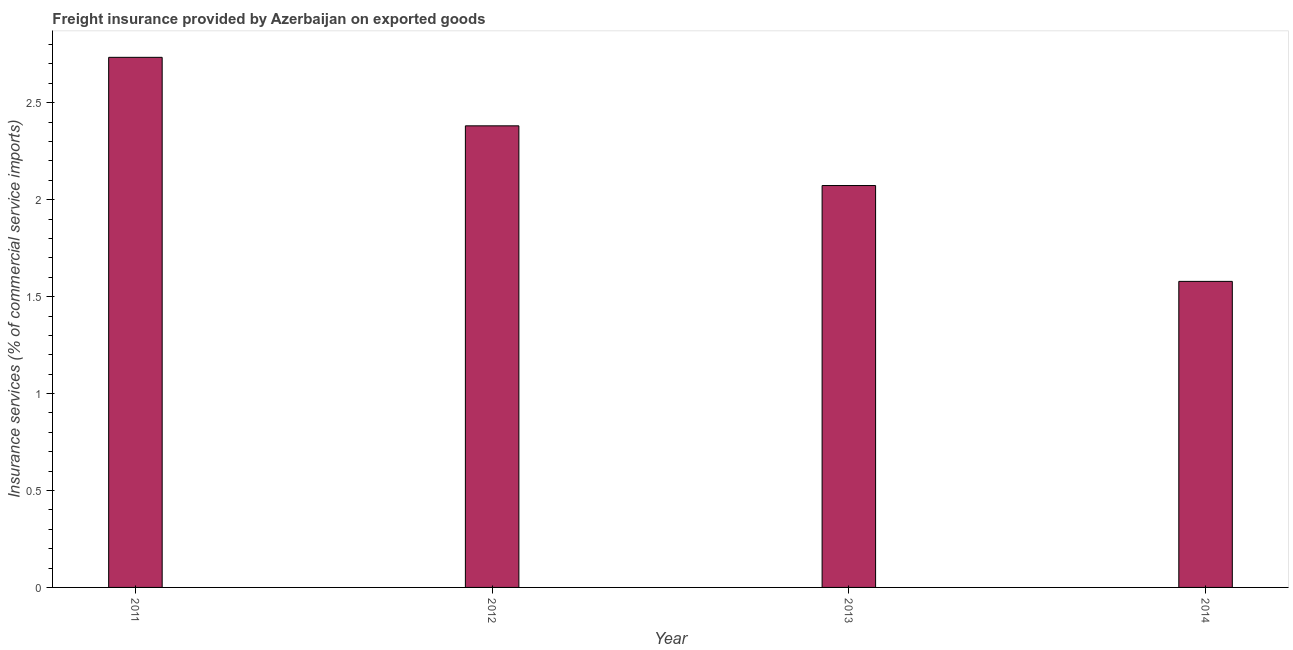What is the title of the graph?
Offer a terse response. Freight insurance provided by Azerbaijan on exported goods . What is the label or title of the Y-axis?
Provide a succinct answer. Insurance services (% of commercial service imports). What is the freight insurance in 2011?
Ensure brevity in your answer.  2.73. Across all years, what is the maximum freight insurance?
Your answer should be compact. 2.73. Across all years, what is the minimum freight insurance?
Your answer should be compact. 1.58. In which year was the freight insurance maximum?
Provide a succinct answer. 2011. In which year was the freight insurance minimum?
Offer a very short reply. 2014. What is the sum of the freight insurance?
Keep it short and to the point. 8.77. What is the difference between the freight insurance in 2012 and 2013?
Ensure brevity in your answer.  0.31. What is the average freight insurance per year?
Keep it short and to the point. 2.19. What is the median freight insurance?
Give a very brief answer. 2.23. In how many years, is the freight insurance greater than 2.7 %?
Make the answer very short. 1. What is the ratio of the freight insurance in 2011 to that in 2013?
Provide a short and direct response. 1.32. Is the freight insurance in 2011 less than that in 2014?
Your answer should be very brief. No. Is the difference between the freight insurance in 2011 and 2014 greater than the difference between any two years?
Offer a very short reply. Yes. What is the difference between the highest and the second highest freight insurance?
Make the answer very short. 0.35. Is the sum of the freight insurance in 2012 and 2013 greater than the maximum freight insurance across all years?
Give a very brief answer. Yes. What is the difference between the highest and the lowest freight insurance?
Offer a terse response. 1.16. In how many years, is the freight insurance greater than the average freight insurance taken over all years?
Make the answer very short. 2. Are all the bars in the graph horizontal?
Ensure brevity in your answer.  No. How many years are there in the graph?
Your answer should be compact. 4. What is the Insurance services (% of commercial service imports) of 2011?
Give a very brief answer. 2.73. What is the Insurance services (% of commercial service imports) of 2012?
Offer a very short reply. 2.38. What is the Insurance services (% of commercial service imports) of 2013?
Ensure brevity in your answer.  2.07. What is the Insurance services (% of commercial service imports) of 2014?
Make the answer very short. 1.58. What is the difference between the Insurance services (% of commercial service imports) in 2011 and 2012?
Your answer should be compact. 0.35. What is the difference between the Insurance services (% of commercial service imports) in 2011 and 2013?
Your response must be concise. 0.66. What is the difference between the Insurance services (% of commercial service imports) in 2011 and 2014?
Your answer should be compact. 1.16. What is the difference between the Insurance services (% of commercial service imports) in 2012 and 2013?
Give a very brief answer. 0.31. What is the difference between the Insurance services (% of commercial service imports) in 2012 and 2014?
Offer a terse response. 0.8. What is the difference between the Insurance services (% of commercial service imports) in 2013 and 2014?
Keep it short and to the point. 0.49. What is the ratio of the Insurance services (% of commercial service imports) in 2011 to that in 2012?
Keep it short and to the point. 1.15. What is the ratio of the Insurance services (% of commercial service imports) in 2011 to that in 2013?
Make the answer very short. 1.32. What is the ratio of the Insurance services (% of commercial service imports) in 2011 to that in 2014?
Offer a terse response. 1.73. What is the ratio of the Insurance services (% of commercial service imports) in 2012 to that in 2013?
Keep it short and to the point. 1.15. What is the ratio of the Insurance services (% of commercial service imports) in 2012 to that in 2014?
Keep it short and to the point. 1.51. What is the ratio of the Insurance services (% of commercial service imports) in 2013 to that in 2014?
Give a very brief answer. 1.31. 